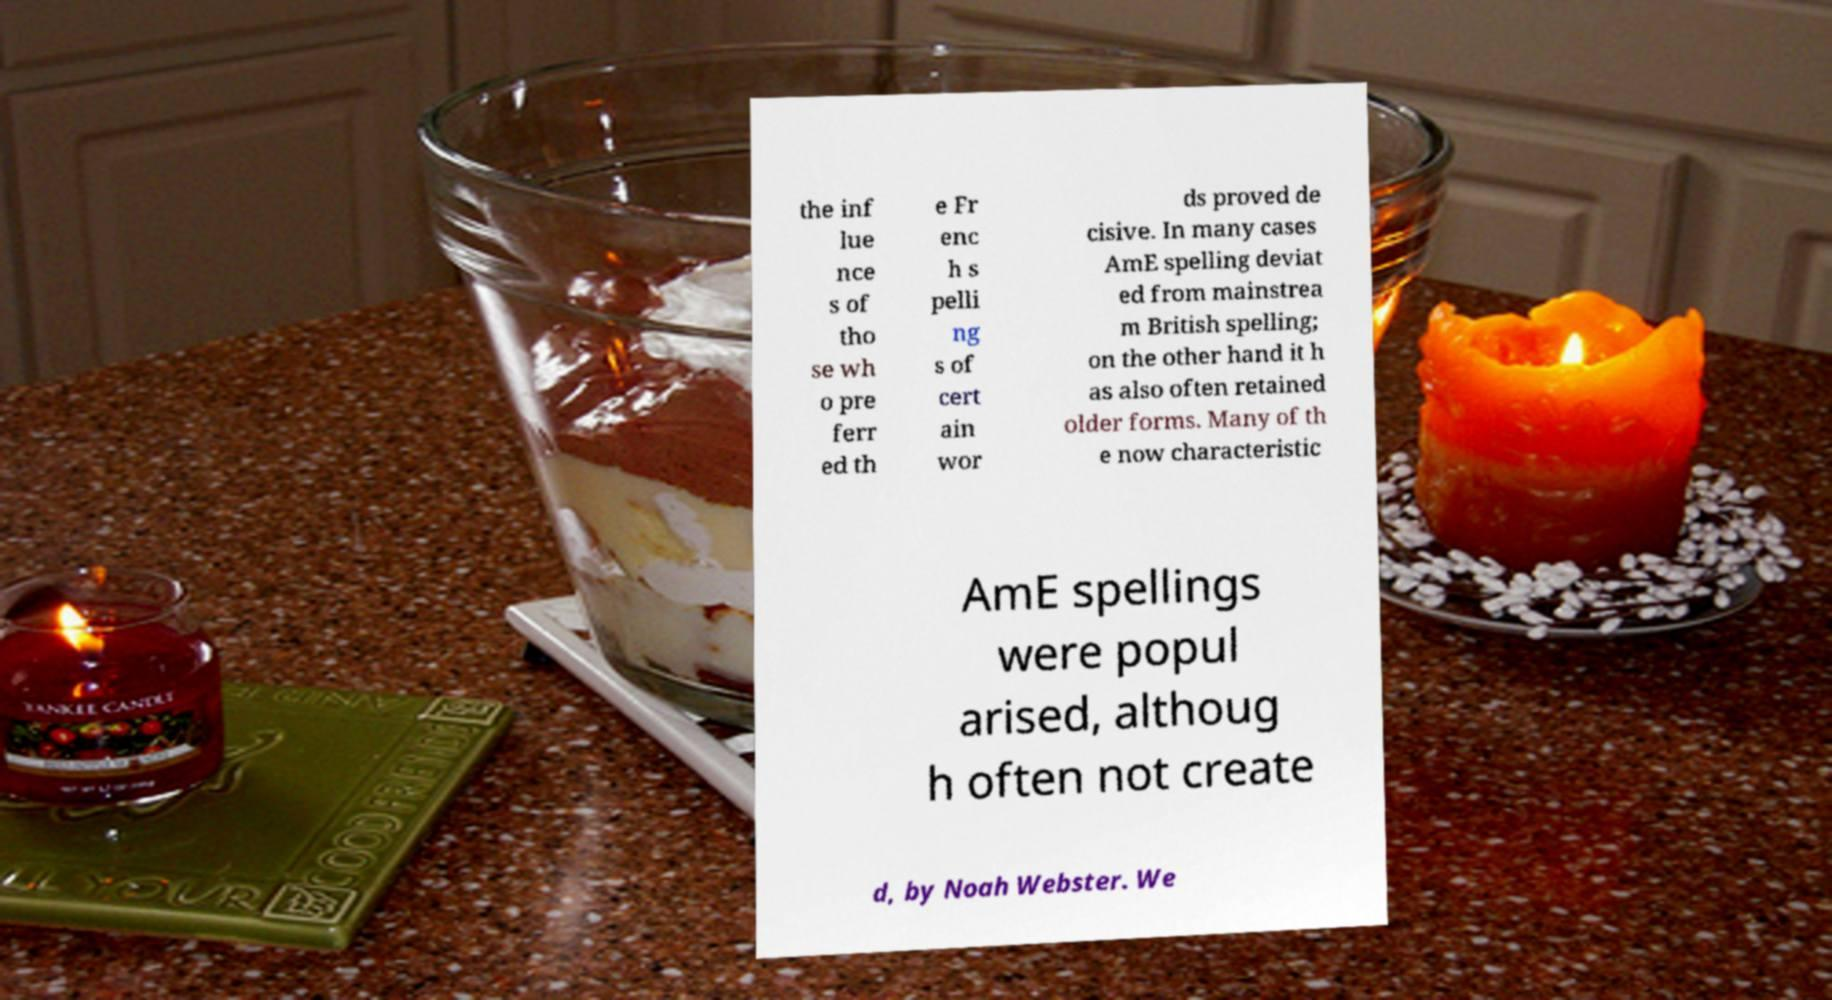Can you read and provide the text displayed in the image?This photo seems to have some interesting text. Can you extract and type it out for me? the inf lue nce s of tho se wh o pre ferr ed th e Fr enc h s pelli ng s of cert ain wor ds proved de cisive. In many cases AmE spelling deviat ed from mainstrea m British spelling; on the other hand it h as also often retained older forms. Many of th e now characteristic AmE spellings were popul arised, althoug h often not create d, by Noah Webster. We 